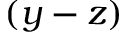Convert formula to latex. <formula><loc_0><loc_0><loc_500><loc_500>( y - z )</formula> 